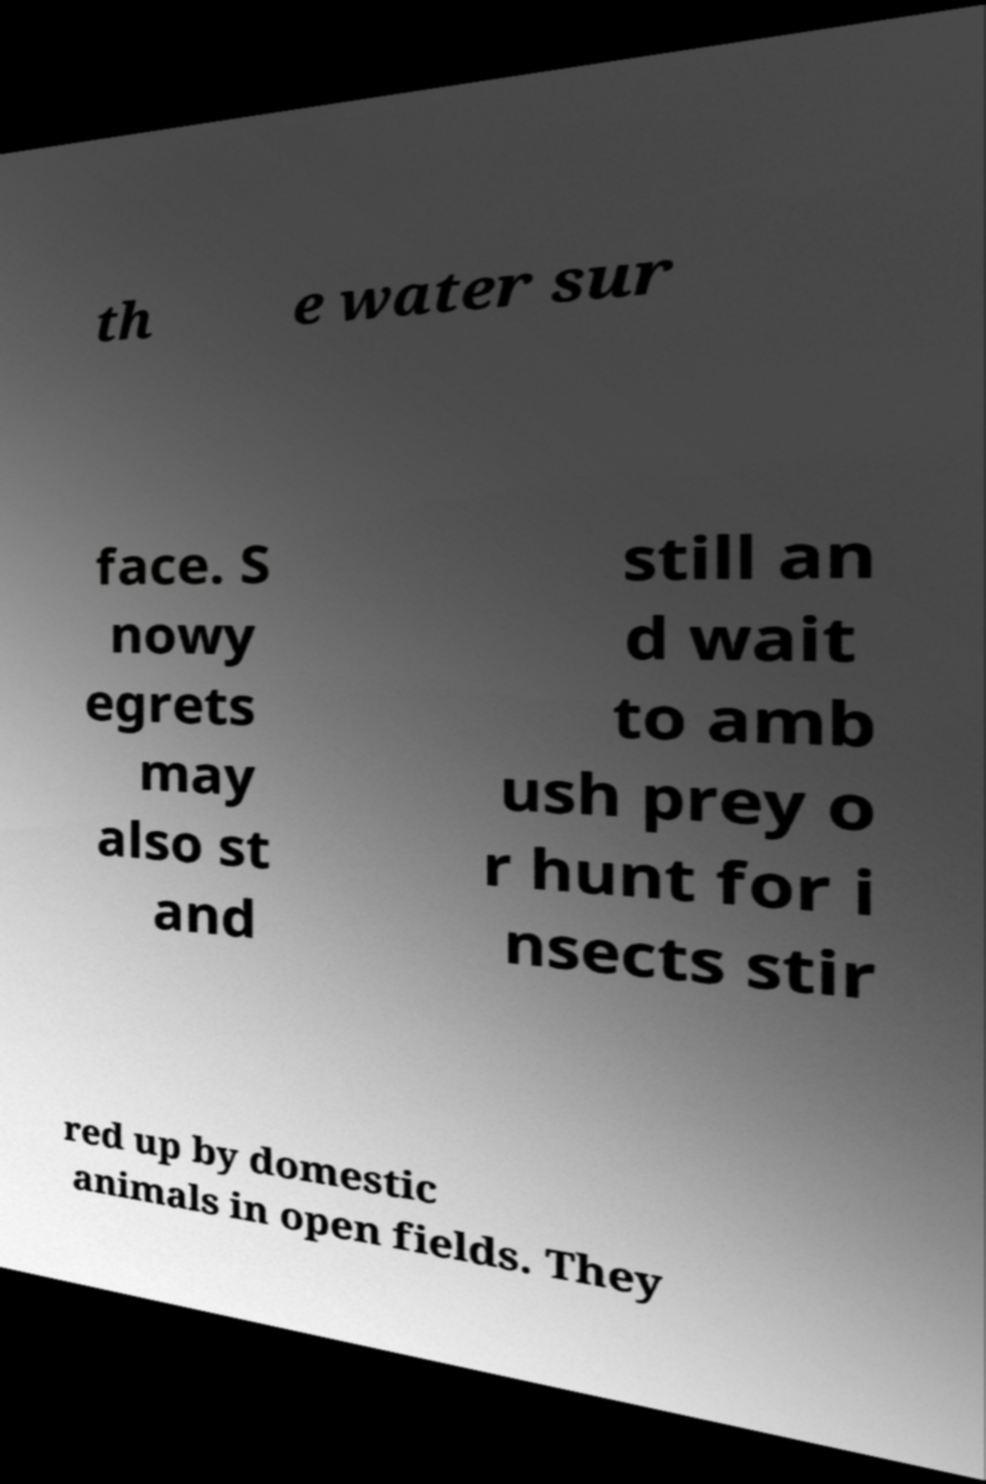I need the written content from this picture converted into text. Can you do that? th e water sur face. S nowy egrets may also st and still an d wait to amb ush prey o r hunt for i nsects stir red up by domestic animals in open fields. They 